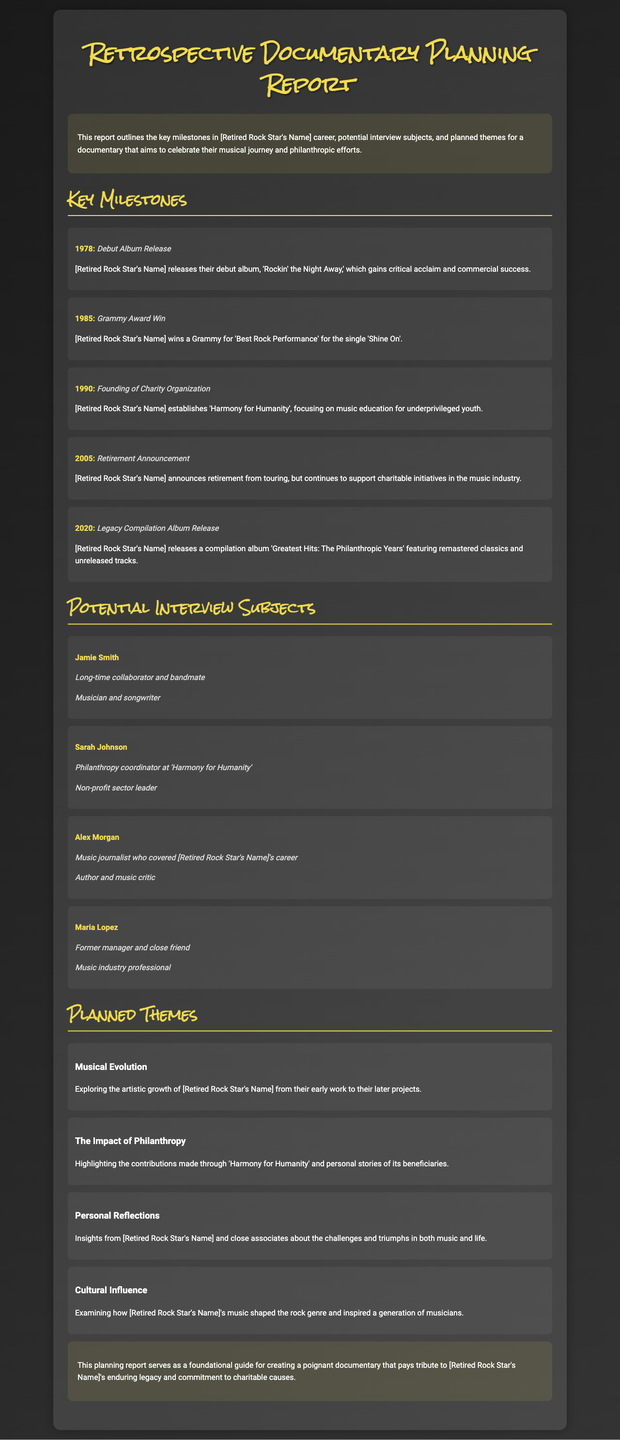what is the title of the documentary? The title of the documentary is not explicitly mentioned in the document.
Answer: Not mentioned when was the debut album released? The debut album was released in the year 1978, as indicated in the key milestones section.
Answer: 1978 what is the name of the charity organization founded? The charity organization founded by the retired rock star is called 'Harmony for Humanity'.
Answer: Harmony for Humanity who won a Grammy Award in 1985? The retired rock star, whose name is not specified, won the Grammy Award for 'Best Rock Performance' in 1985.
Answer: [Retired Rock Star's Name] what theme focuses on personal experiences related to music and life? The theme that focuses on personal experiences related to music and life is titled 'Personal Reflections'.
Answer: Personal Reflections who is a music journalist that covered the retired rock star's career? Alex Morgan is identified as a music journalist who covered the retired rock star's career.
Answer: Alex Morgan what event occurred in 2005? In 2005, the retired rock star announced retirement from touring.
Answer: Retirement Announcement how many key milestones are listed in the document? There are five key milestones listed in the document.
Answer: Five what is the focus of the theme titled 'The Impact of Philanthropy'? This theme highlights the contributions made through 'Harmony for Humanity' and personal stories of its beneficiaries.
Answer: Contributions through 'Harmony for Humanity' 